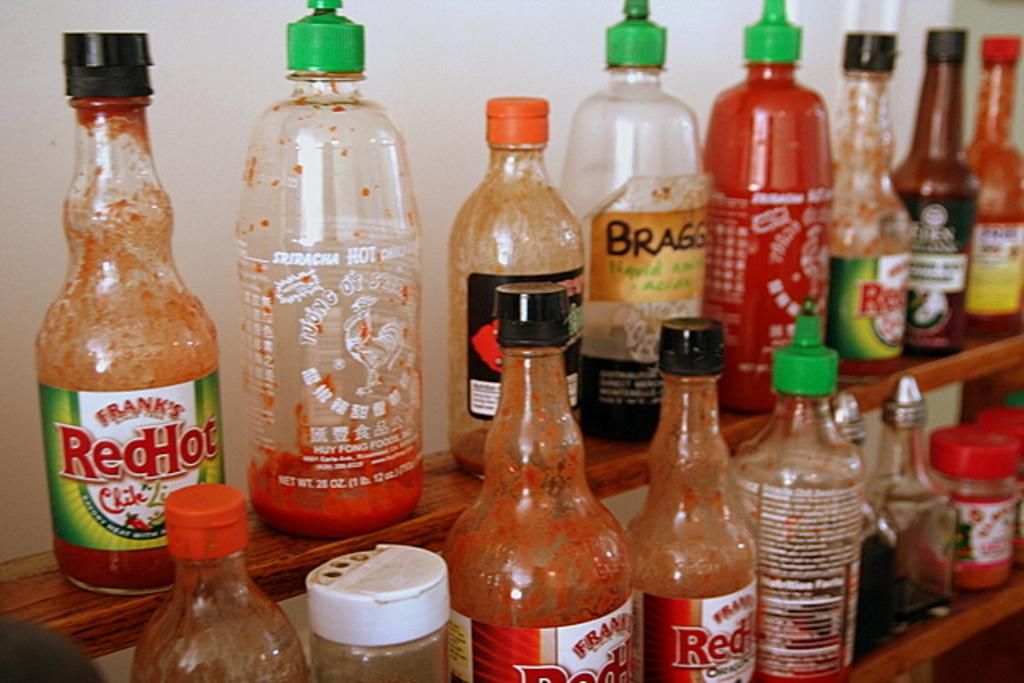<image>
Describe the image concisely. Several kinds of hot sauce are lined up on two shelves, including Frank's Red Hot. 